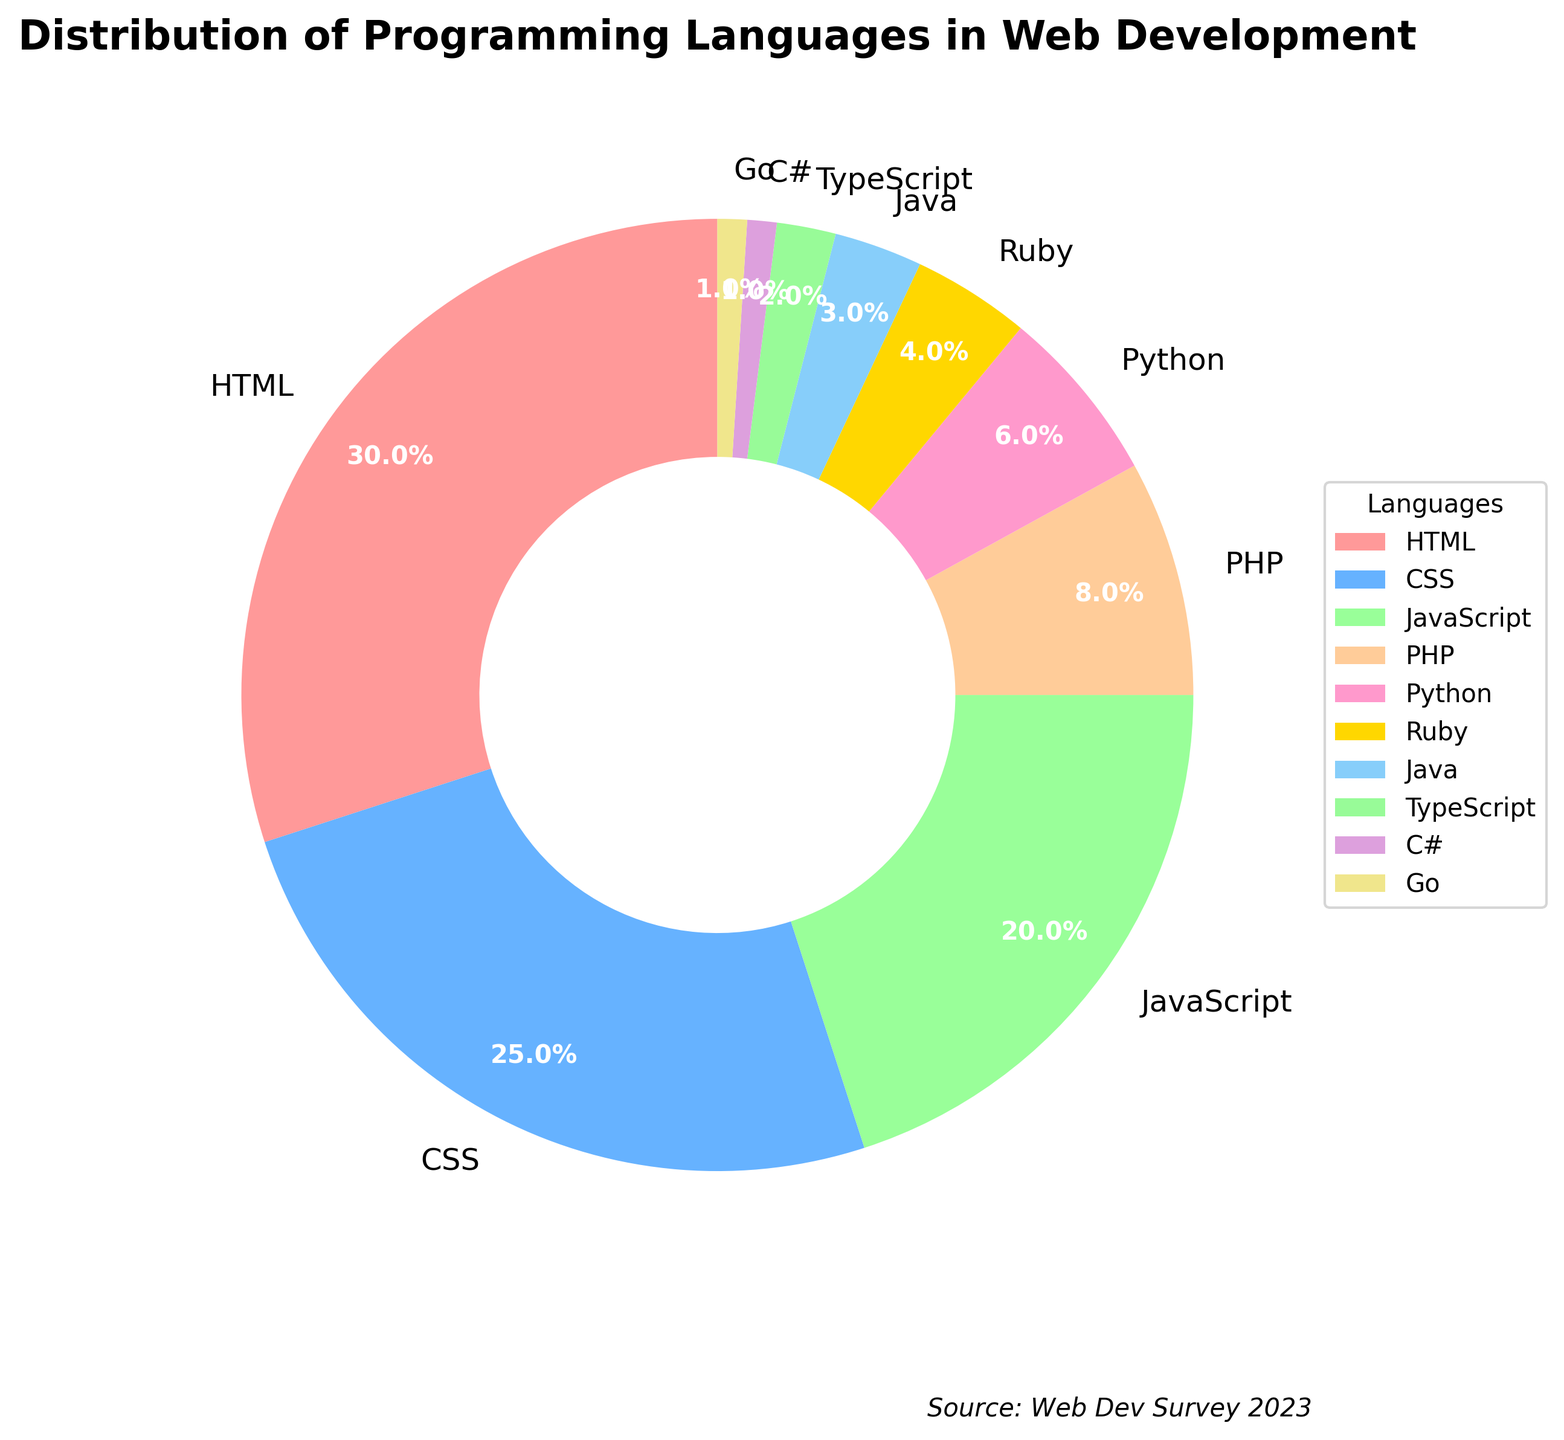Which language has the highest percentage used in web development? By examining the pie chart, the largest section of the pie is labeled with the language "HTML" followed by the percentage "30%". This indicates that HTML has the highest usage.
Answer: HTML What is the combined percentage of PHP and Python used in web development? According to the figure, the percentage for PHP is 8% and for Python is 6%. Adding these together gives 8% + 6% = 14%.
Answer: 14% How does the usage of CSS compare to the usage of JavaScript? From the chart, CSS usage is 25% while JavaScript is 20%. Hence, CSS is used more than JavaScript by a difference of 25% - 20% = 5%.
Answer: CSS is used 5% more Which two languages have the closest percentages in usage? The languages with the closest percentages in usage are TypeScript (2%) and C# (1%). The difference between their usages is minimal.
Answer: TypeScript and C# What color represents Python in the pie chart? Observing the pie chart, the section labeled "Python" is filled with a green color.
Answer: Green How many languages have a usage percentage below 5%? The chart shows Ruby (4%), Java (3%), TypeScript (2%), C# (1%), and Go (1%), totaling 5 languages under 5% usage.
Answer: 5 languages Is the percentage usage of HTML greater than the combined percentage usage of Ruby, Java, TypeScript, C#, and Go? HTML usage is 30%. Summing the usage percentages of Ruby (4%), Java (3%), TypeScript (2%), C# (1%), and Go (1%) gives 4% + 3% + 2% + 1% + 1% = 11%. Since 30% > 11%, HTML indeed has a greater usage percentage than the combined usage of these five languages.
Answer: Yes What's the difference between the highest and lowest usage percentages in the chart? HTML has the highest usage at 30%, and both C# and Go have the lowest usage at 1%. The difference between 30% and 1% is 30% - 1% = 29%.
Answer: 29% Which languages together constitute exactly half of the total percentage of usage? HTML (30%) and CSS (25%) together add up to 30% + 25% = 55%, which is more than half. Reducing to incorporate other languages, the exact possibilities like CSS (25%) + JavaScript (20%) + PHP (8%) = 25% + 20% + 8% = 53%, or a closer composition is a combination below 50%.
Answer: No exact match with the given data 